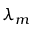Convert formula to latex. <formula><loc_0><loc_0><loc_500><loc_500>\lambda _ { m }</formula> 